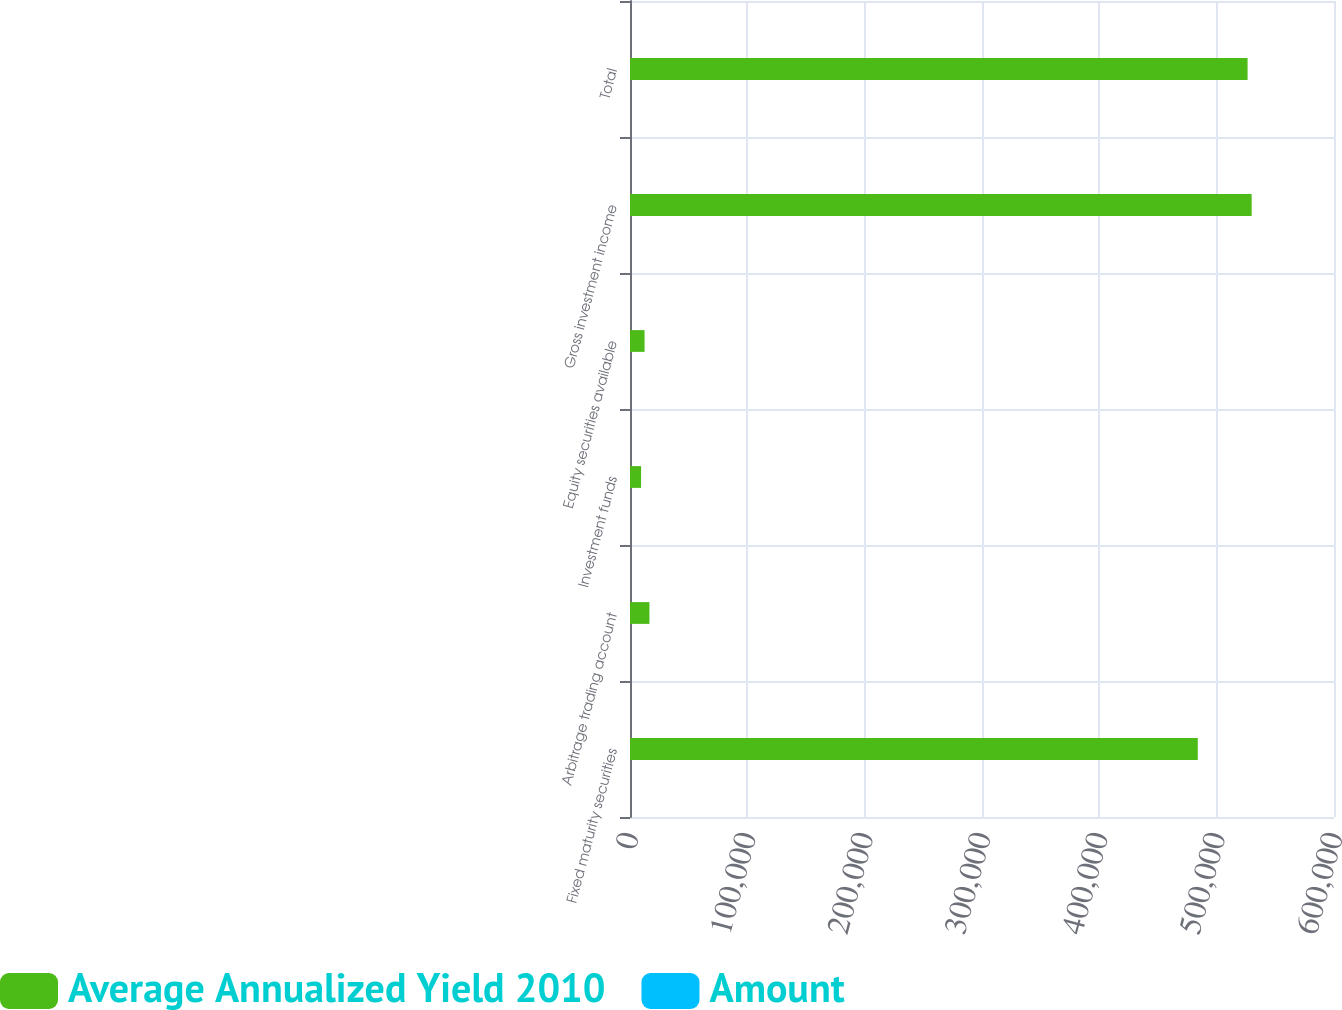Convert chart to OTSL. <chart><loc_0><loc_0><loc_500><loc_500><stacked_bar_chart><ecel><fcel>Fixed maturity securities<fcel>Arbitrage trading account<fcel>Investment funds<fcel>Equity securities available<fcel>Gross investment income<fcel>Total<nl><fcel>Average Annualized Yield 2010<fcel>483905<fcel>16576<fcel>9452<fcel>12416<fcel>529820<fcel>526351<nl><fcel>Amount<fcel>4<fcel>4.9<fcel>1.6<fcel>3.5<fcel>3.9<fcel>3.9<nl></chart> 